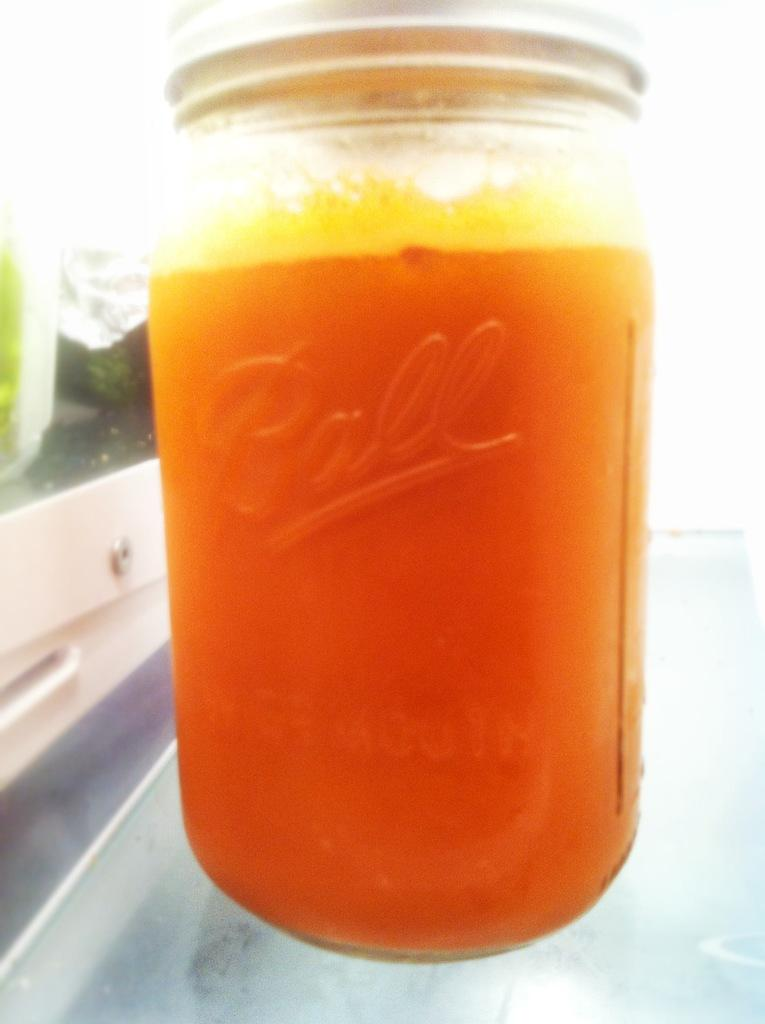What is the main object in the center of the image? There is a bottle in the center of the image. What type of rice is being cooked in the image? There is no rice present in the image; it only features a bottle. What color wristband is visible on the person in the image? There is no person present in the image, only a bottle. 